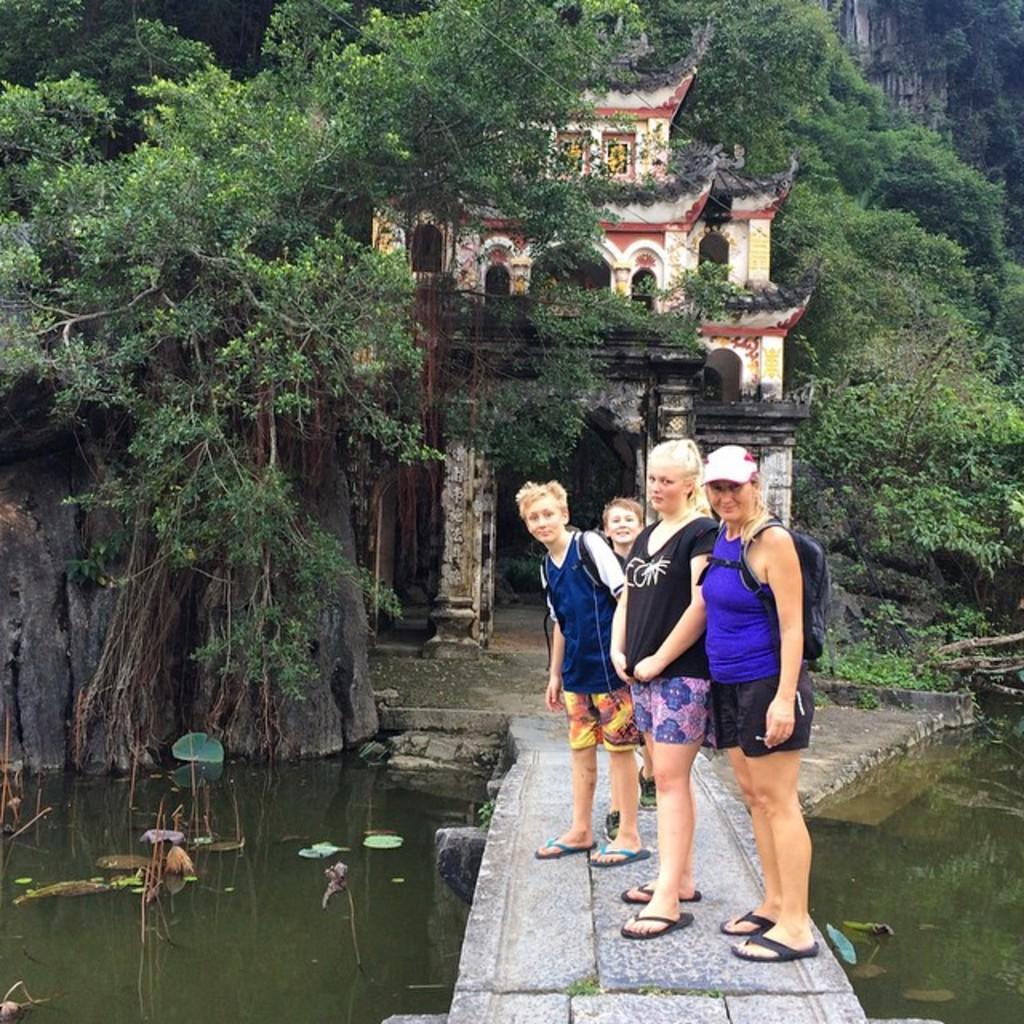Can you describe this image briefly? As we can see in the image there is a bridge, group of people standing over here, water, trees, buildings and tree. 